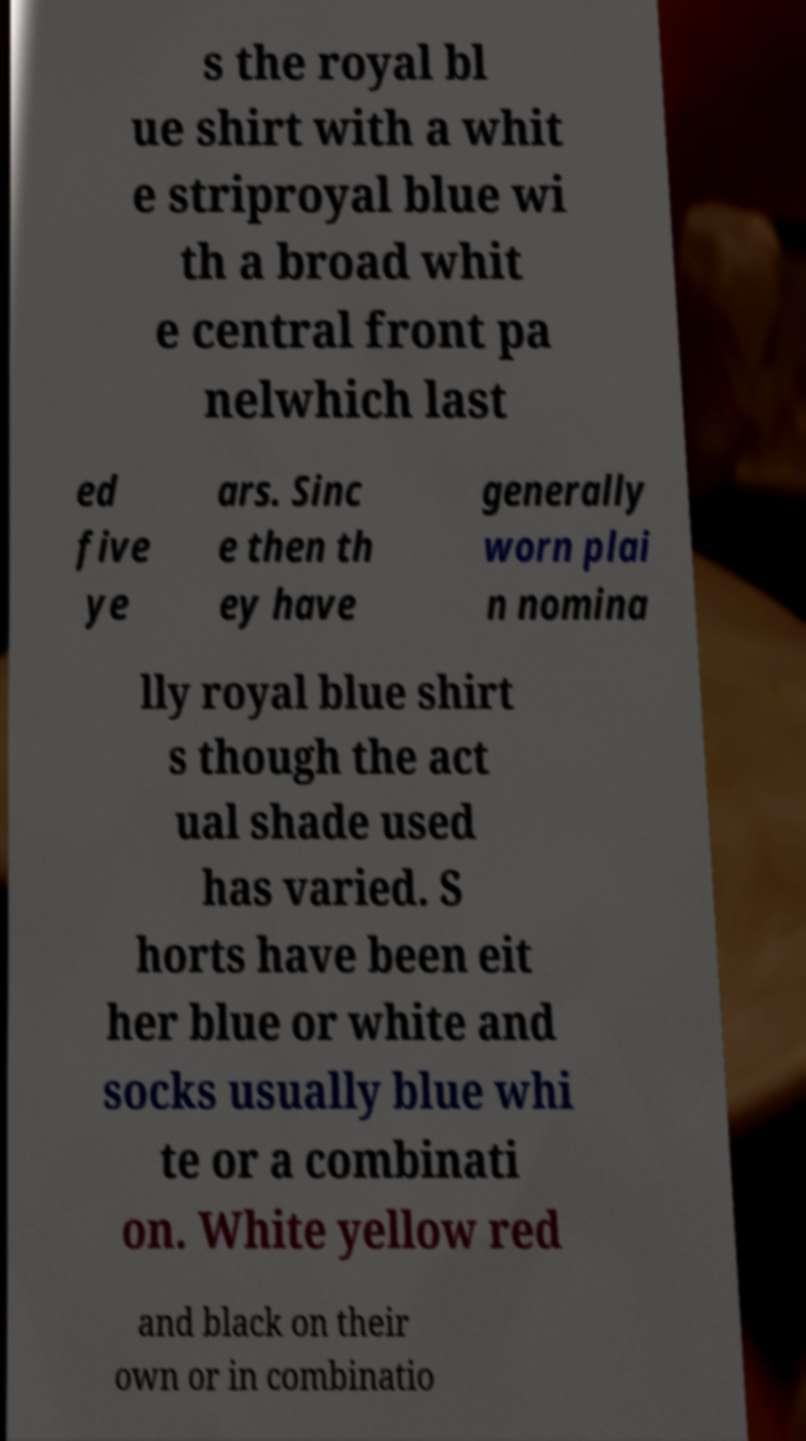Please read and relay the text visible in this image. What does it say? s the royal bl ue shirt with a whit e striproyal blue wi th a broad whit e central front pa nelwhich last ed five ye ars. Sinc e then th ey have generally worn plai n nomina lly royal blue shirt s though the act ual shade used has varied. S horts have been eit her blue or white and socks usually blue whi te or a combinati on. White yellow red and black on their own or in combinatio 